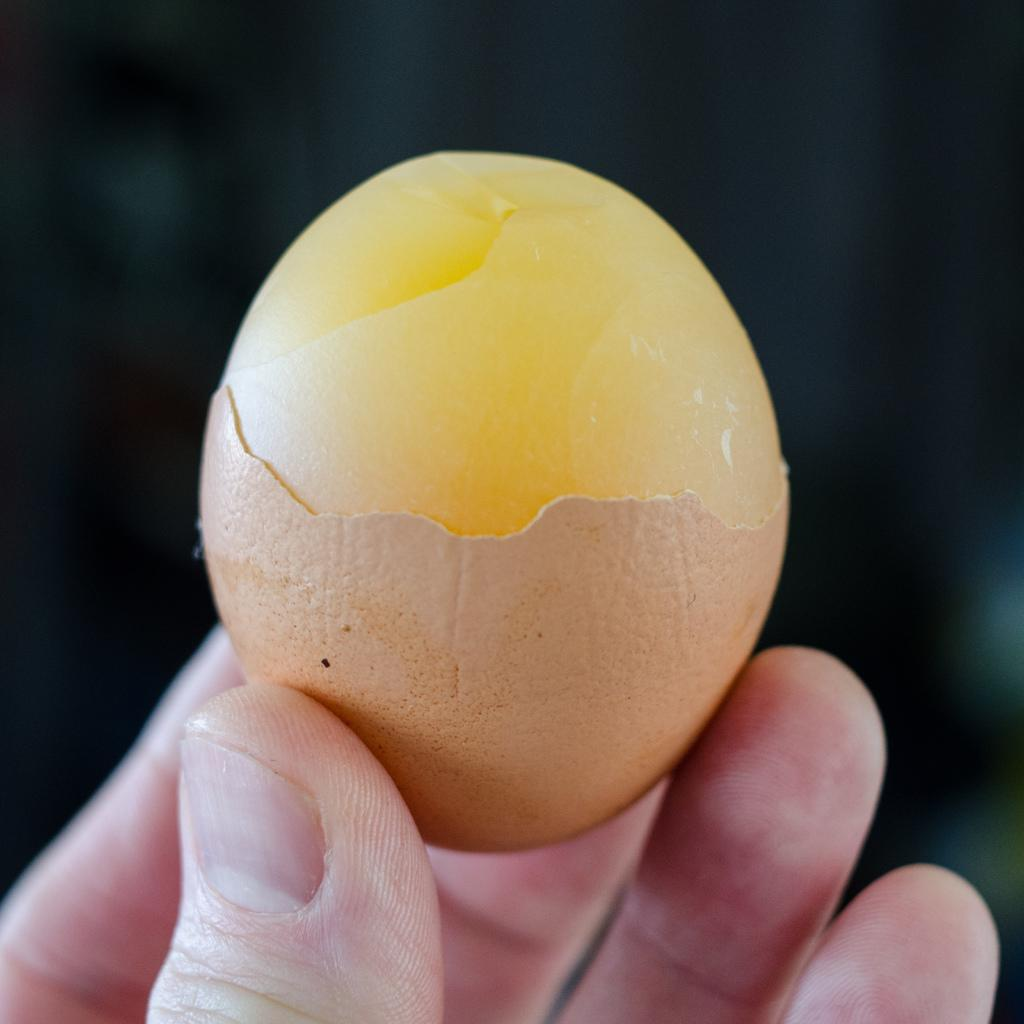What is the main subject of the image? The main subject of the image is a human hand. What is the hand holding in the image? The hand is holding an egg in the image. What color is the background of the image? The background of the image is black in color. Can you see any baseball players in the image? There are no baseball players present in the image. Is there any steam coming from the egg in the image? There is no steam visible in the image. 